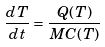<formula> <loc_0><loc_0><loc_500><loc_500>\frac { d T } { d t } = \frac { Q ( T ) } { M C ( T ) }</formula> 